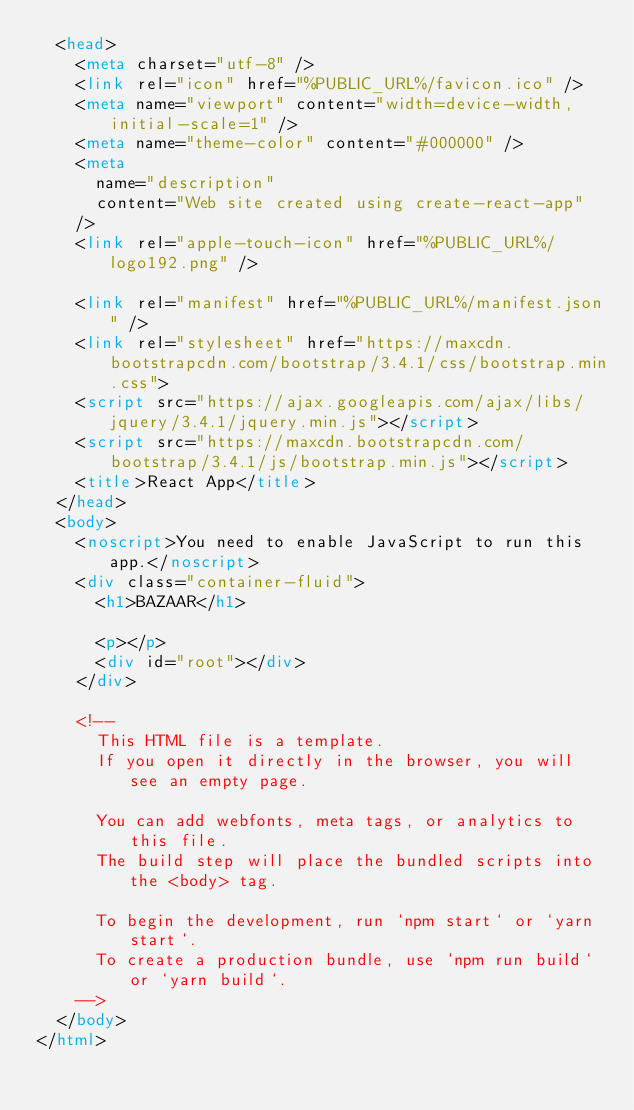<code> <loc_0><loc_0><loc_500><loc_500><_HTML_>  <head>
    <meta charset="utf-8" />
    <link rel="icon" href="%PUBLIC_URL%/favicon.ico" />
    <meta name="viewport" content="width=device-width, initial-scale=1" />
    <meta name="theme-color" content="#000000" />
    <meta
      name="description"
      content="Web site created using create-react-app"
    />
    <link rel="apple-touch-icon" href="%PUBLIC_URL%/logo192.png" />
    
    <link rel="manifest" href="%PUBLIC_URL%/manifest.json" />
    <link rel="stylesheet" href="https://maxcdn.bootstrapcdn.com/bootstrap/3.4.1/css/bootstrap.min.css">
    <script src="https://ajax.googleapis.com/ajax/libs/jquery/3.4.1/jquery.min.js"></script>
    <script src="https://maxcdn.bootstrapcdn.com/bootstrap/3.4.1/js/bootstrap.min.js"></script>
    <title>React App</title>
  </head>
  <body>
    <noscript>You need to enable JavaScript to run this app.</noscript>
    <div class="container-fluid">
      <h1>BAZAAR</h1>      
      
      <p></p>   
      <div id="root"></div>        
    </div>
   
    <!--
      This HTML file is a template.
      If you open it directly in the browser, you will see an empty page.

      You can add webfonts, meta tags, or analytics to this file.
      The build step will place the bundled scripts into the <body> tag.

      To begin the development, run `npm start` or `yarn start`.
      To create a production bundle, use `npm run build` or `yarn build`.
    -->
  </body>
</html>
</code> 